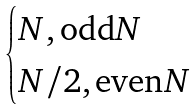<formula> <loc_0><loc_0><loc_500><loc_500>\begin{cases} N , \text {odd} N \\ N / 2 , \text {even} N \end{cases}</formula> 